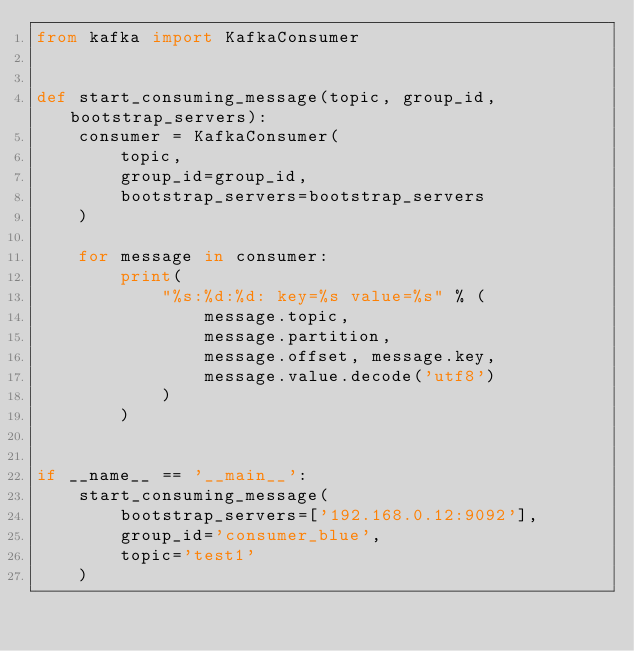<code> <loc_0><loc_0><loc_500><loc_500><_Python_>from kafka import KafkaConsumer


def start_consuming_message(topic, group_id, bootstrap_servers):
    consumer = KafkaConsumer(
        topic,
        group_id=group_id,
        bootstrap_servers=bootstrap_servers
    )

    for message in consumer:
        print(
            "%s:%d:%d: key=%s value=%s" % (
                message.topic,
                message.partition,
                message.offset, message.key,
                message.value.decode('utf8')
            )
        )


if __name__ == '__main__':
    start_consuming_message(
        bootstrap_servers=['192.168.0.12:9092'],
        group_id='consumer_blue',
        topic='test1'
    )
</code> 